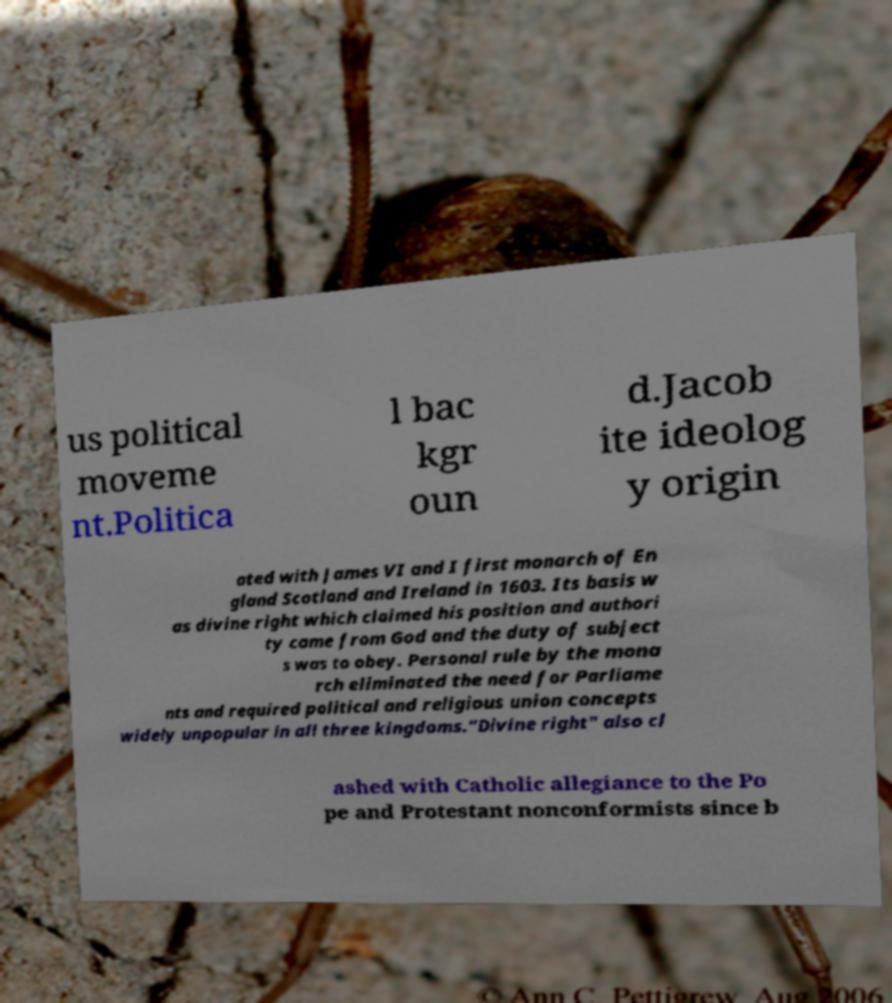Could you extract and type out the text from this image? us political moveme nt.Politica l bac kgr oun d.Jacob ite ideolog y origin ated with James VI and I first monarch of En gland Scotland and Ireland in 1603. Its basis w as divine right which claimed his position and authori ty came from God and the duty of subject s was to obey. Personal rule by the mona rch eliminated the need for Parliame nts and required political and religious union concepts widely unpopular in all three kingdoms."Divine right" also cl ashed with Catholic allegiance to the Po pe and Protestant nonconformists since b 